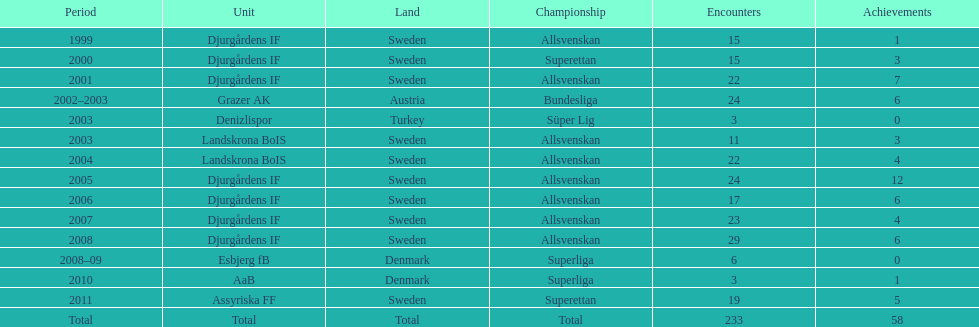How many matches did jones kusi-asare play in in his first season? 15. 